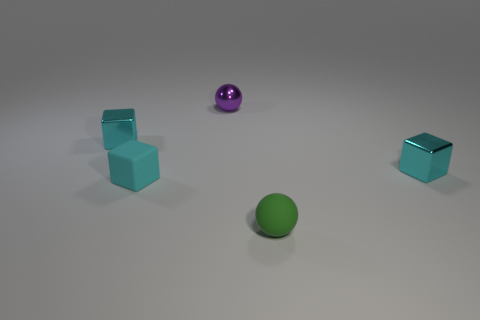Are there any patterns or repeats in the arrangement of these objects? The objects are arranged symmetrically in pairs by shape; two balls opposite each other with the cubes placed in between, forming a diagonal line with respect to the image frame. This reflects a conscious decision to create a sense of balance in the composition. 